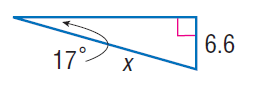Question: Find x.
Choices:
A. 11.4
B. 22.6
C. 32.3
D. 43.2
Answer with the letter. Answer: B 